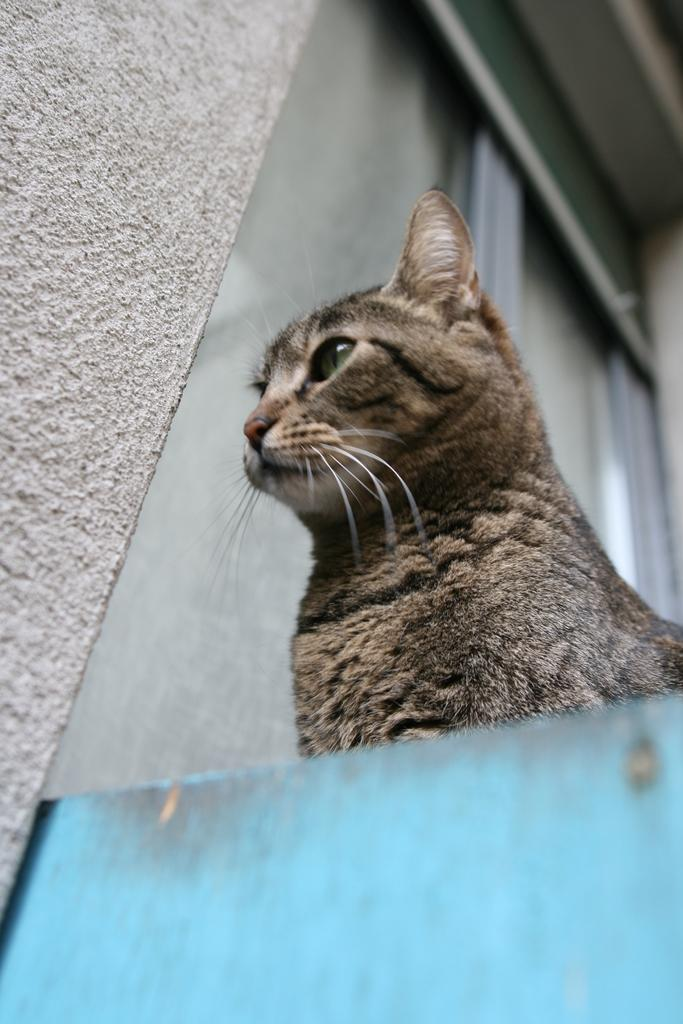What is the main subject of the image? There is a cat in the center of the image. Can you describe the background of the image? There is a wall in the background of the image. What historical event is depicted in the image? There is no historical event depicted in the image; it features a cat in the center and a wall in the background. What type of office furniture can be seen in the image? There is no office furniture present in the image. 